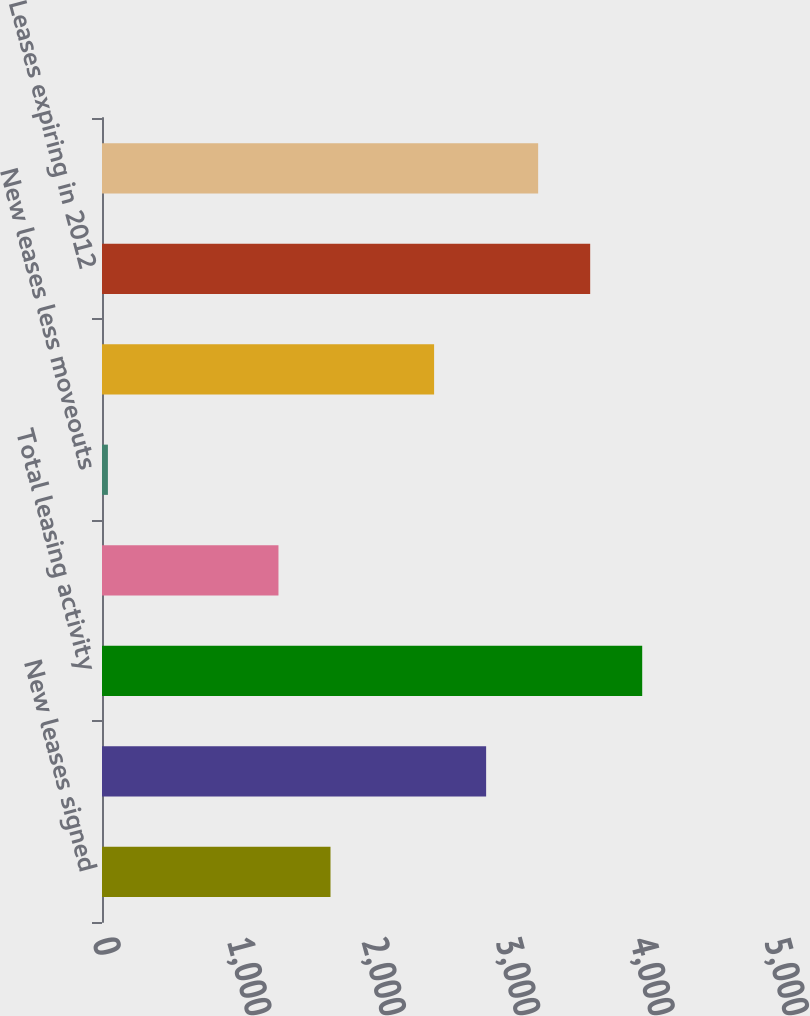Convert chart to OTSL. <chart><loc_0><loc_0><loc_500><loc_500><bar_chart><fcel>New leases signed<fcel>Existing leases renewed<fcel>Total leasing activity<fcel>Leases moved out<fcel>New leases less moveouts<fcel>Leases expiring in 2011<fcel>Leases expiring in 2012<fcel>Leases expiring in 2013<nl><fcel>1700.1<fcel>2858.1<fcel>4019.4<fcel>1313<fcel>44<fcel>2471<fcel>3632.3<fcel>3245.2<nl></chart> 